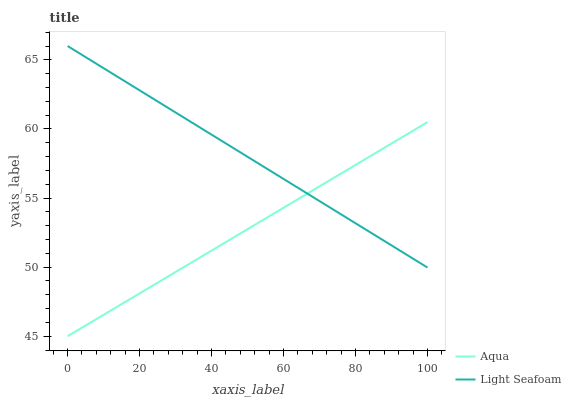Does Aqua have the minimum area under the curve?
Answer yes or no. Yes. Does Light Seafoam have the maximum area under the curve?
Answer yes or no. Yes. Does Aqua have the maximum area under the curve?
Answer yes or no. No. Is Aqua the smoothest?
Answer yes or no. Yes. Is Light Seafoam the roughest?
Answer yes or no. Yes. Is Aqua the roughest?
Answer yes or no. No. Does Aqua have the lowest value?
Answer yes or no. Yes. Does Light Seafoam have the highest value?
Answer yes or no. Yes. Does Aqua have the highest value?
Answer yes or no. No. Does Light Seafoam intersect Aqua?
Answer yes or no. Yes. Is Light Seafoam less than Aqua?
Answer yes or no. No. Is Light Seafoam greater than Aqua?
Answer yes or no. No. 